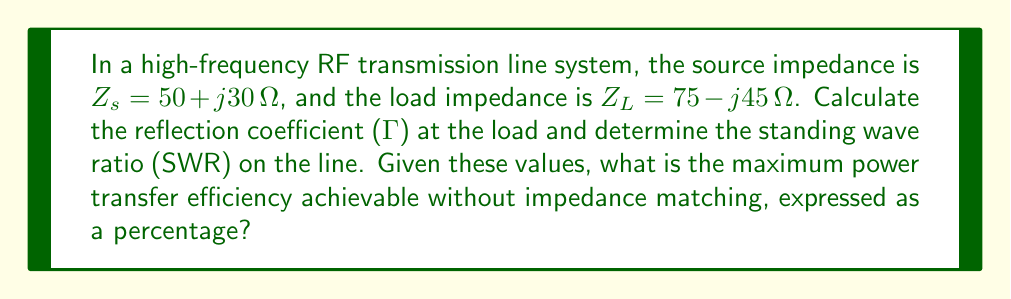Give your solution to this math problem. Let's approach this step-by-step:

1) First, we need to calculate the reflection coefficient ($\Gamma$) at the load. The formula for $\Gamma$ is:

   $$\Gamma = \frac{Z_L - Z_0}{Z_L + Z_0}$$

   where $Z_0$ is the characteristic impedance of the line, typically 50 Ω for RF systems.

2) Substituting the values:

   $$\Gamma = \frac{(75 - j45) - 50}{(75 - j45) + 50} = \frac{25 - j45}{125 - j45}$$

3) To simplify this complex fraction, multiply numerator and denominator by the complex conjugate of the denominator:

   $$\Gamma = \frac{(25 - j45)(125 + j45)}{(125 - j45)(125 + j45)} = \frac{4375 + j2250}{15625 + 2025} = \frac{4375 + j2250}{17650}$$

4) This gives us:

   $$\Gamma = 0.2478 + j0.1275$$

5) The magnitude of $\Gamma$ is:

   $$|\Gamma| = \sqrt{0.2478^2 + 0.1275^2} = 0.2787$$

6) Now, we can calculate the Standing Wave Ratio (SWR):

   $$SWR = \frac{1 + |\Gamma|}{1 - |\Gamma|} = \frac{1 + 0.2787}{1 - 0.2787} = 1.7743$$

7) To calculate the maximum power transfer efficiency, we use the formula:

   $$\text{Efficiency} = (1 - |\Gamma|^2) \times 100\%$$

8) Substituting our value for $|\Gamma|$:

   $$\text{Efficiency} = (1 - 0.2787^2) \times 100\% = 92.23\%$$

Therefore, the maximum power transfer efficiency achievable without impedance matching is 92.23%.
Answer: 92.23% 